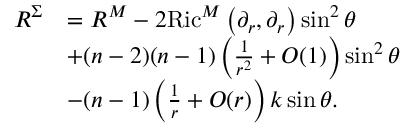<formula> <loc_0><loc_0><loc_500><loc_500>\begin{array} { r l } { R ^ { \Sigma } } & { = R ^ { M } - 2 R i c ^ { M } \left ( \partial _ { r } , \partial _ { r } \right ) \sin ^ { 2 } \theta } \\ & { + ( n - 2 ) ( n - 1 ) \left ( \frac { 1 } { r ^ { 2 } } + O ( 1 ) \right ) \sin ^ { 2 } \theta } \\ & { - ( n - 1 ) \left ( \frac { 1 } { r } + O ( r ) \right ) k \sin \theta . } \end{array}</formula> 